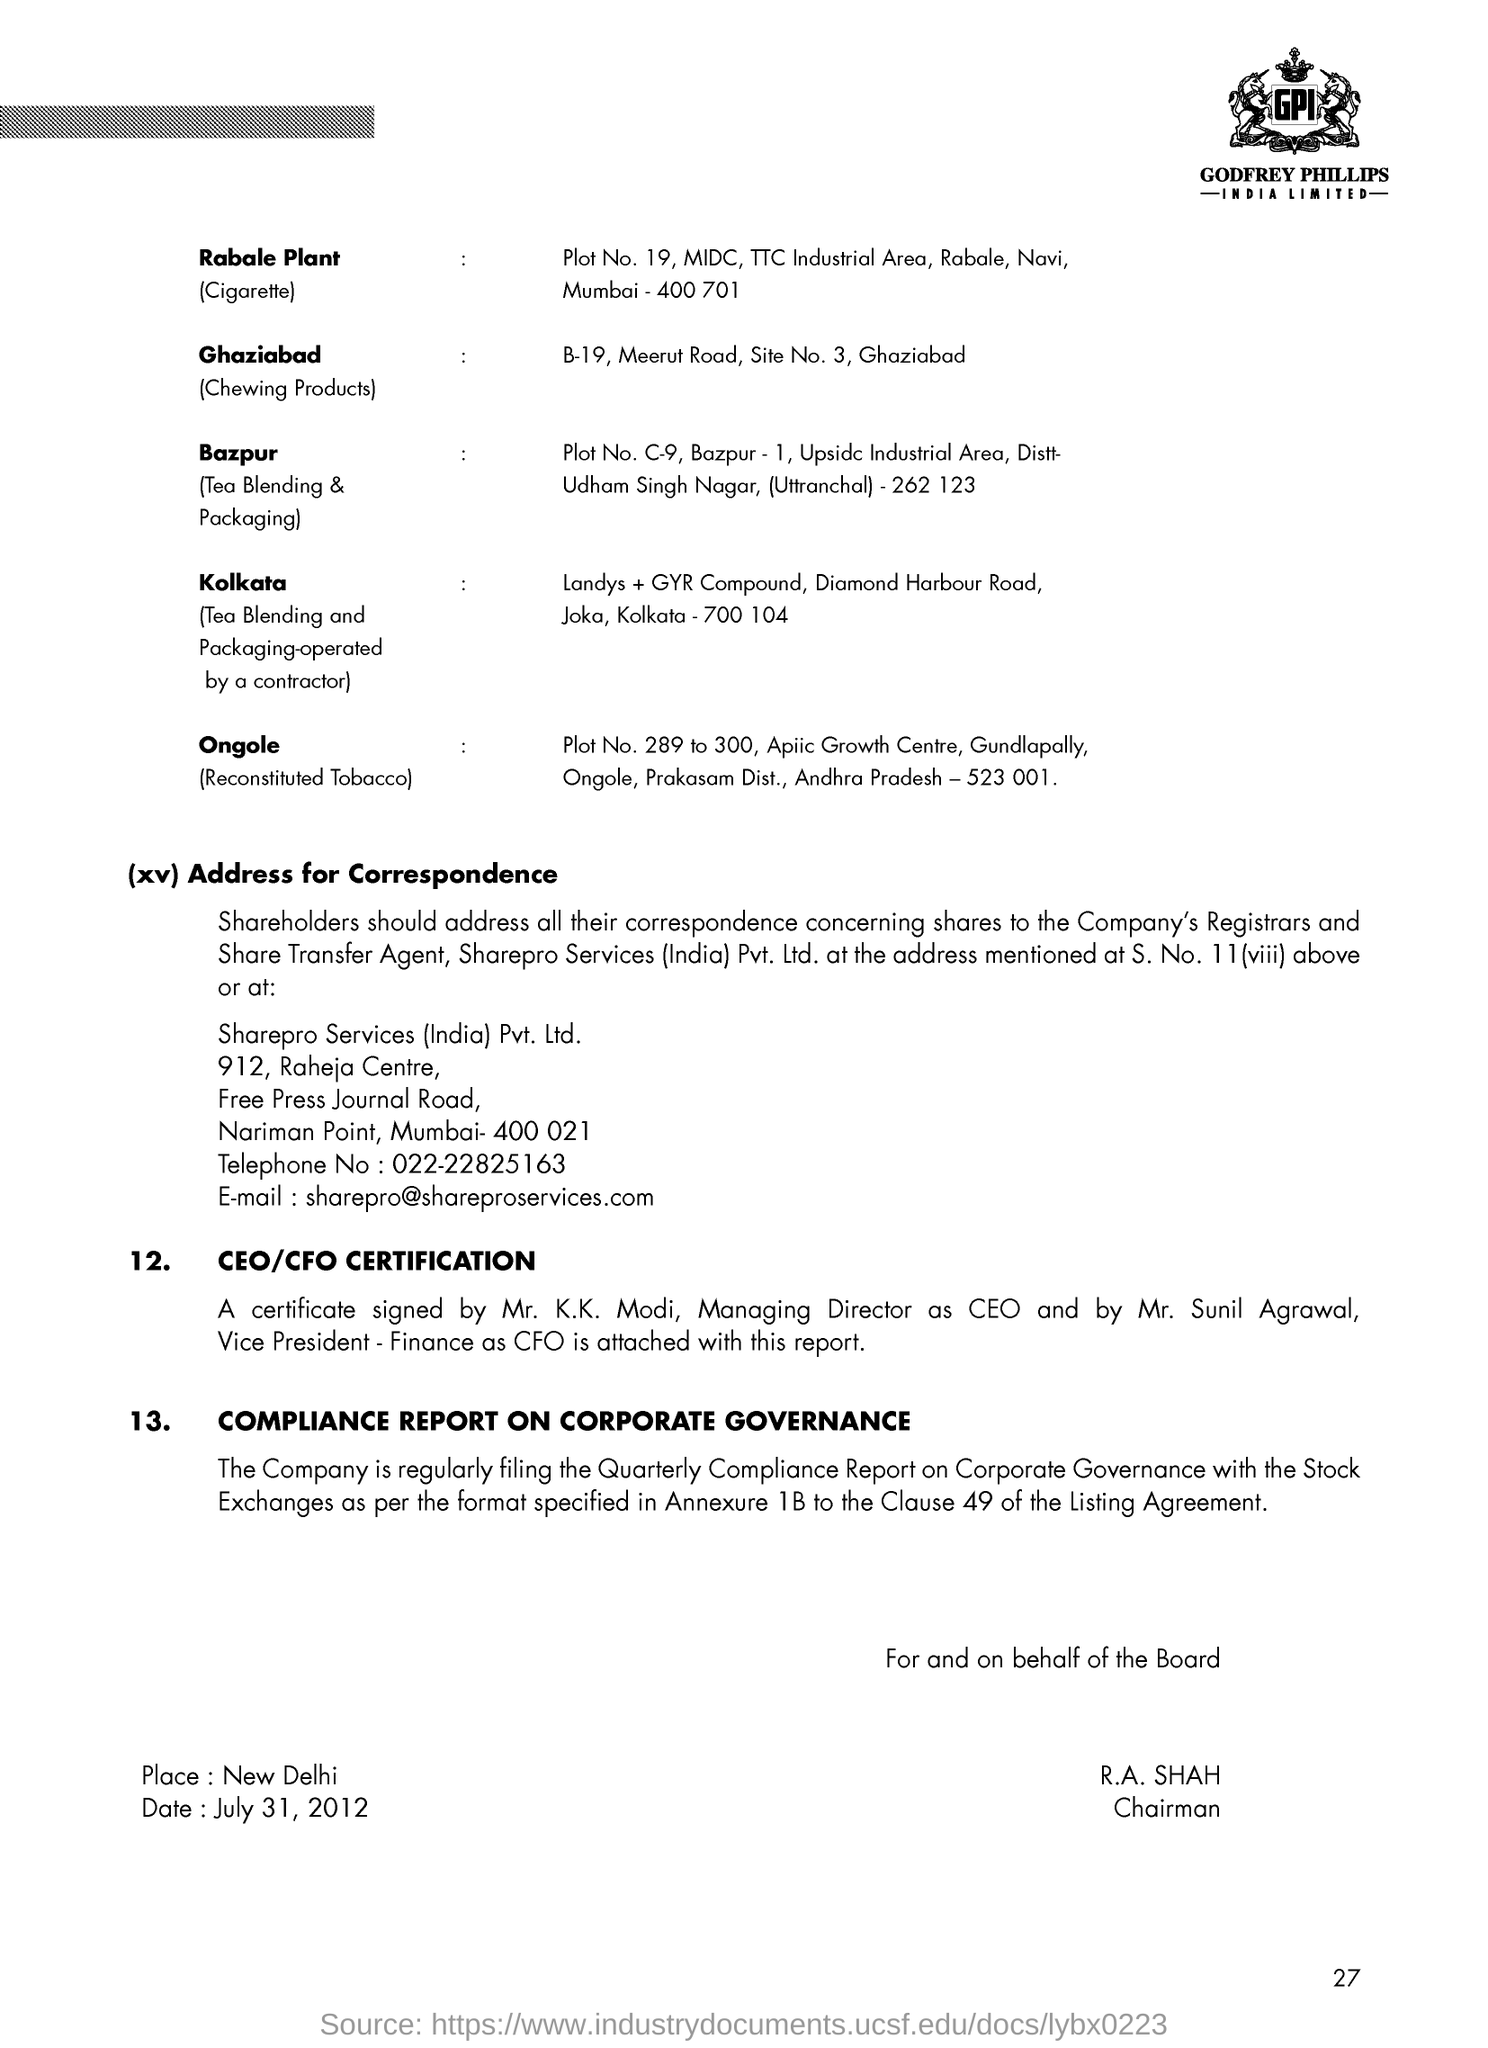List a handful of essential elements in this visual. The email address is [what is the email id? sharepro@shareproservices.com...]. The telephone number is 022-22825163. The date mentioned in the document is July 31, 2012. Page 27 is the current page. The Chairman is R.A. Shah. 